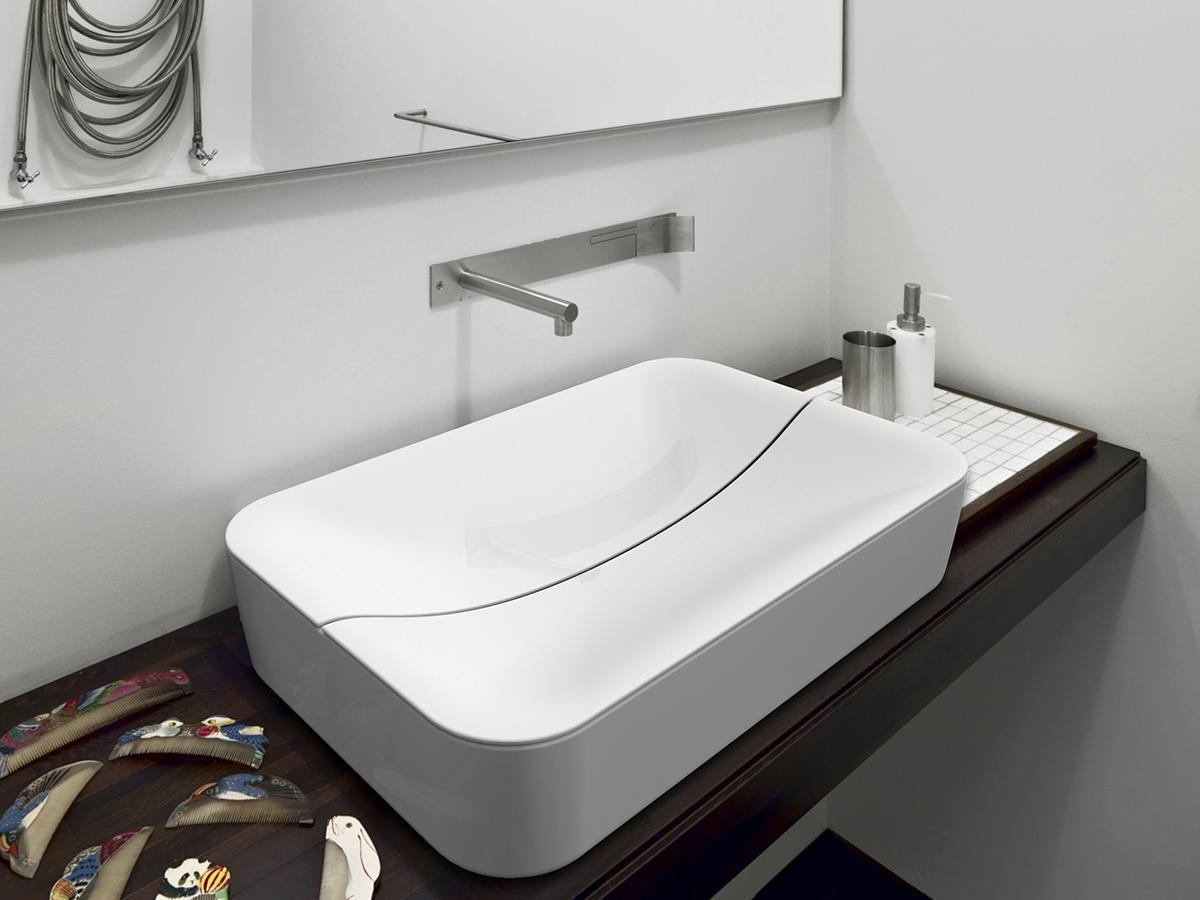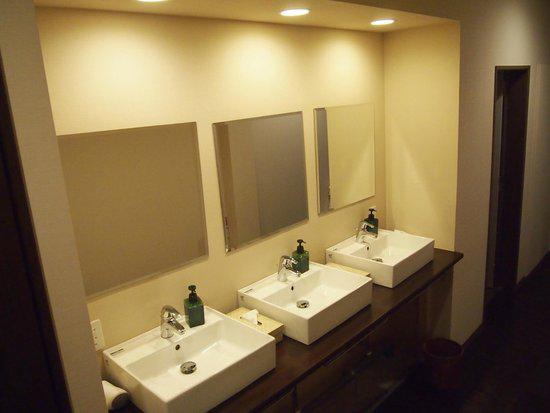The first image is the image on the left, the second image is the image on the right. Given the left and right images, does the statement "Three faucets are attached directly to the sink porcelain." hold true? Answer yes or no. Yes. The first image is the image on the left, the second image is the image on the right. Assess this claim about the two images: "In total, three sink basins are shown.". Correct or not? Answer yes or no. No. 